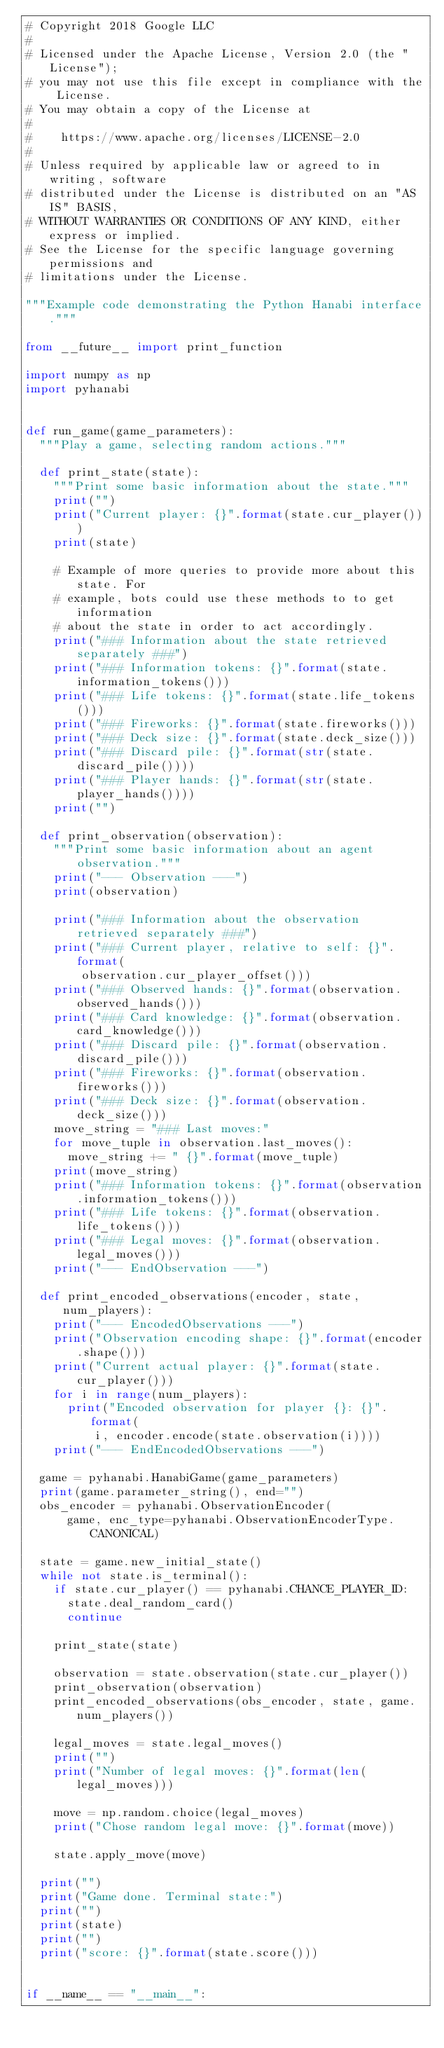<code> <loc_0><loc_0><loc_500><loc_500><_Python_># Copyright 2018 Google LLC
#
# Licensed under the Apache License, Version 2.0 (the "License");
# you may not use this file except in compliance with the License.
# You may obtain a copy of the License at
#
#    https://www.apache.org/licenses/LICENSE-2.0
#
# Unless required by applicable law or agreed to in writing, software
# distributed under the License is distributed on an "AS IS" BASIS,
# WITHOUT WARRANTIES OR CONDITIONS OF ANY KIND, either express or implied.
# See the License for the specific language governing permissions and
# limitations under the License.

"""Example code demonstrating the Python Hanabi interface."""

from __future__ import print_function

import numpy as np
import pyhanabi


def run_game(game_parameters):
  """Play a game, selecting random actions."""

  def print_state(state):
    """Print some basic information about the state."""
    print("")
    print("Current player: {}".format(state.cur_player()))
    print(state)

    # Example of more queries to provide more about this state. For
    # example, bots could use these methods to to get information
    # about the state in order to act accordingly.
    print("### Information about the state retrieved separately ###")
    print("### Information tokens: {}".format(state.information_tokens()))
    print("### Life tokens: {}".format(state.life_tokens()))
    print("### Fireworks: {}".format(state.fireworks()))
    print("### Deck size: {}".format(state.deck_size()))
    print("### Discard pile: {}".format(str(state.discard_pile())))
    print("### Player hands: {}".format(str(state.player_hands())))
    print("")

  def print_observation(observation):
    """Print some basic information about an agent observation."""
    print("--- Observation ---")
    print(observation)

    print("### Information about the observation retrieved separately ###")
    print("### Current player, relative to self: {}".format(
        observation.cur_player_offset()))
    print("### Observed hands: {}".format(observation.observed_hands()))
    print("### Card knowledge: {}".format(observation.card_knowledge()))
    print("### Discard pile: {}".format(observation.discard_pile()))
    print("### Fireworks: {}".format(observation.fireworks()))
    print("### Deck size: {}".format(observation.deck_size()))
    move_string = "### Last moves:"
    for move_tuple in observation.last_moves():
      move_string += " {}".format(move_tuple)
    print(move_string)
    print("### Information tokens: {}".format(observation.information_tokens()))
    print("### Life tokens: {}".format(observation.life_tokens()))
    print("### Legal moves: {}".format(observation.legal_moves()))
    print("--- EndObservation ---")

  def print_encoded_observations(encoder, state, num_players):
    print("--- EncodedObservations ---")
    print("Observation encoding shape: {}".format(encoder.shape()))
    print("Current actual player: {}".format(state.cur_player()))
    for i in range(num_players):
      print("Encoded observation for player {}: {}".format(
          i, encoder.encode(state.observation(i))))
    print("--- EndEncodedObservations ---")

  game = pyhanabi.HanabiGame(game_parameters)
  print(game.parameter_string(), end="")
  obs_encoder = pyhanabi.ObservationEncoder(
      game, enc_type=pyhanabi.ObservationEncoderType.CANONICAL)

  state = game.new_initial_state()
  while not state.is_terminal():
    if state.cur_player() == pyhanabi.CHANCE_PLAYER_ID:
      state.deal_random_card()
      continue

    print_state(state)

    observation = state.observation(state.cur_player())
    print_observation(observation)
    print_encoded_observations(obs_encoder, state, game.num_players())

    legal_moves = state.legal_moves()
    print("")
    print("Number of legal moves: {}".format(len(legal_moves)))

    move = np.random.choice(legal_moves)
    print("Chose random legal move: {}".format(move))

    state.apply_move(move)

  print("")
  print("Game done. Terminal state:")
  print("")
  print(state)
  print("")
  print("score: {}".format(state.score()))


if __name__ == "__main__":</code> 